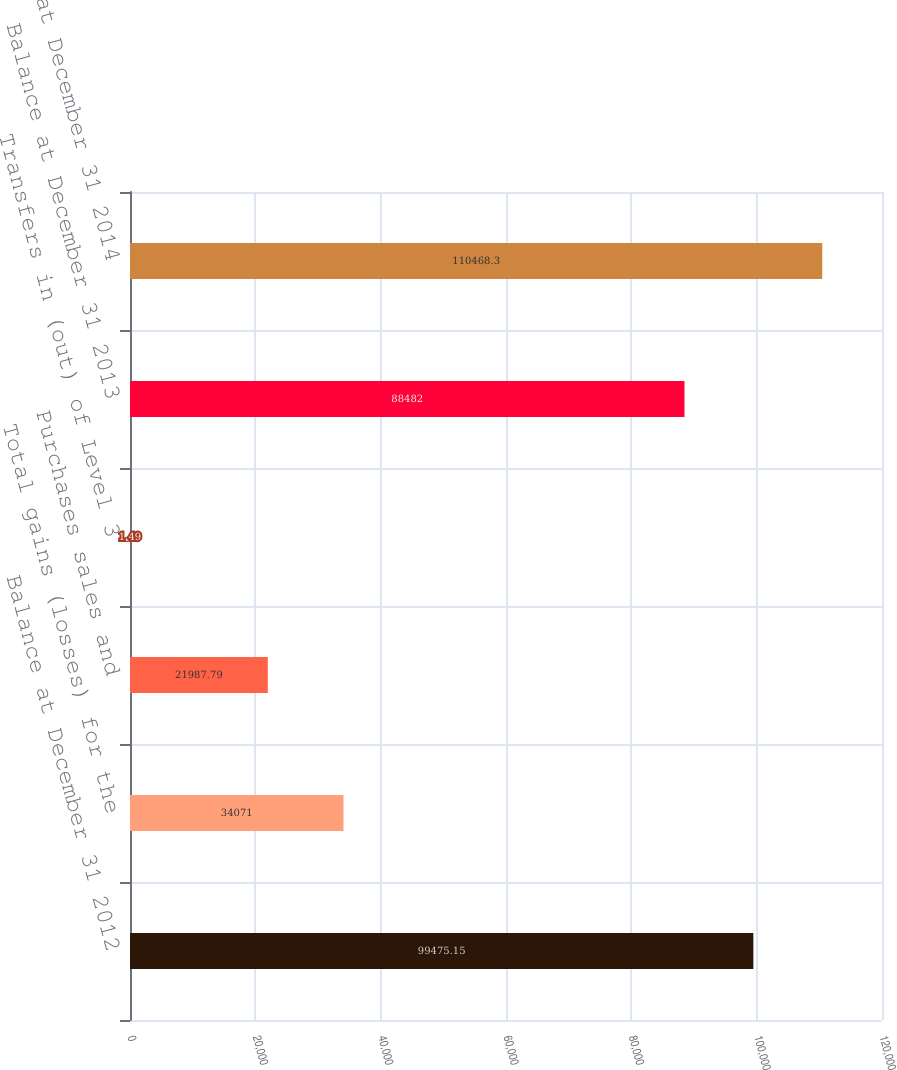Convert chart to OTSL. <chart><loc_0><loc_0><loc_500><loc_500><bar_chart><fcel>Balance at December 31 2012<fcel>Total gains (losses) for the<fcel>Purchases sales and<fcel>Transfers in (out) of Level 3<fcel>Balance at December 31 2013<fcel>Balance at December 31 2014<nl><fcel>99475.1<fcel>34071<fcel>21987.8<fcel>1.49<fcel>88482<fcel>110468<nl></chart> 